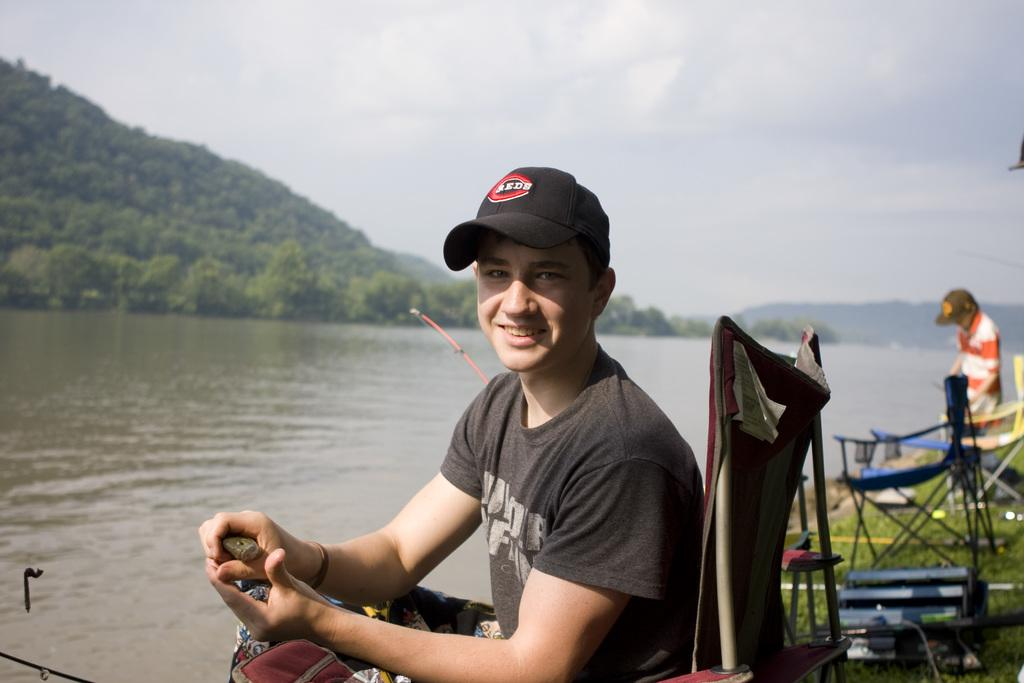What type of vegetation can be seen in the image? There are trees in the image. What part of the natural environment is visible in the image? The sky is visible in the image. What is the body of water in the image? There is water in the image. What is the boy doing in the image? The boy is sitting in the image. How many children are wearing masks in the image? There are no children or masks present in the image. What type of hands can be seen interacting with the water in the image? There are no hands visible in the image; only the boy is present. 